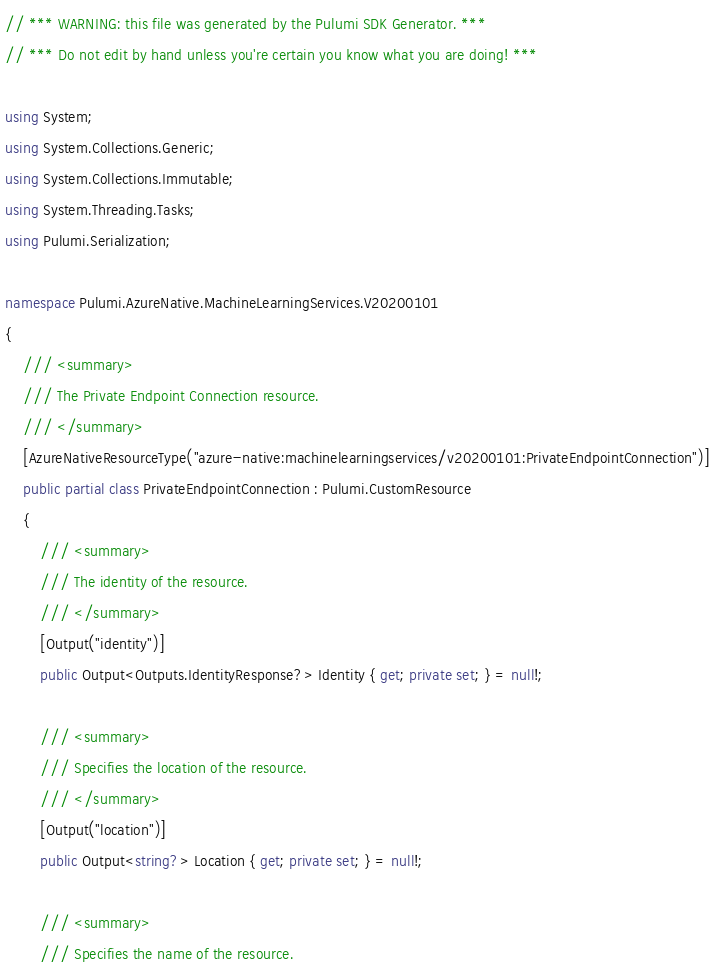Convert code to text. <code><loc_0><loc_0><loc_500><loc_500><_C#_>// *** WARNING: this file was generated by the Pulumi SDK Generator. ***
// *** Do not edit by hand unless you're certain you know what you are doing! ***

using System;
using System.Collections.Generic;
using System.Collections.Immutable;
using System.Threading.Tasks;
using Pulumi.Serialization;

namespace Pulumi.AzureNative.MachineLearningServices.V20200101
{
    /// <summary>
    /// The Private Endpoint Connection resource.
    /// </summary>
    [AzureNativeResourceType("azure-native:machinelearningservices/v20200101:PrivateEndpointConnection")]
    public partial class PrivateEndpointConnection : Pulumi.CustomResource
    {
        /// <summary>
        /// The identity of the resource.
        /// </summary>
        [Output("identity")]
        public Output<Outputs.IdentityResponse?> Identity { get; private set; } = null!;

        /// <summary>
        /// Specifies the location of the resource.
        /// </summary>
        [Output("location")]
        public Output<string?> Location { get; private set; } = null!;

        /// <summary>
        /// Specifies the name of the resource.</code> 